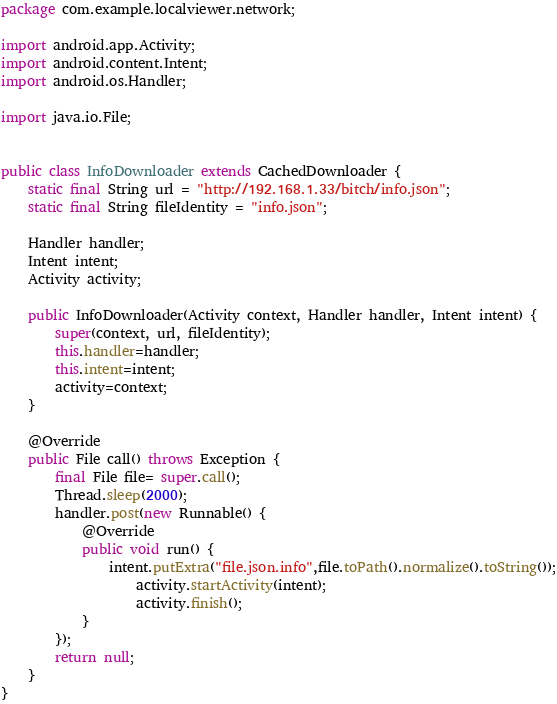<code> <loc_0><loc_0><loc_500><loc_500><_Java_>package com.example.localviewer.network;

import android.app.Activity;
import android.content.Intent;
import android.os.Handler;

import java.io.File;


public class InfoDownloader extends CachedDownloader {
    static final String url = "http://192.168.1.33/bitch/info.json";
    static final String fileIdentity = "info.json";

    Handler handler;
    Intent intent;
    Activity activity;

    public InfoDownloader(Activity context, Handler handler, Intent intent) {
        super(context, url, fileIdentity);
        this.handler=handler;
        this.intent=intent;
        activity=context;
    }

    @Override
    public File call() throws Exception {
        final File file= super.call();
        Thread.sleep(2000);
        handler.post(new Runnable() {
            @Override
            public void run() {
                intent.putExtra("file.json.info",file.toPath().normalize().toString());
                    activity.startActivity(intent);
                    activity.finish();
            }
        });
        return null;
    }
}
</code> 